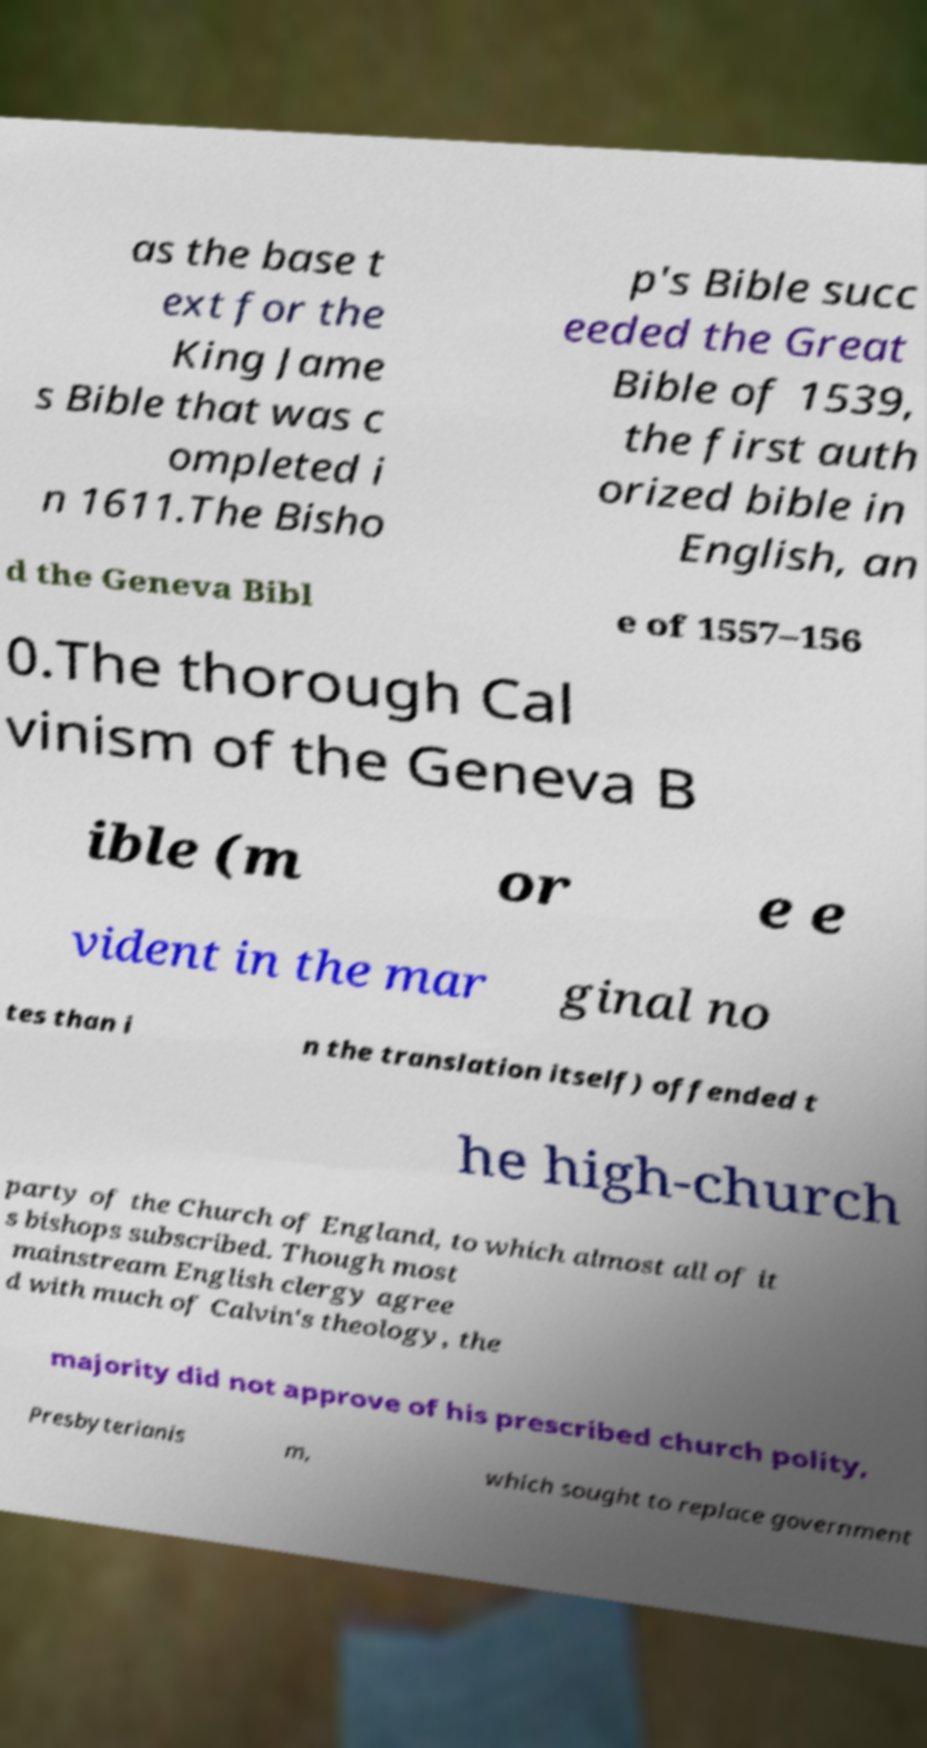I need the written content from this picture converted into text. Can you do that? as the base t ext for the King Jame s Bible that was c ompleted i n 1611.The Bisho p's Bible succ eeded the Great Bible of 1539, the first auth orized bible in English, an d the Geneva Bibl e of 1557–156 0.The thorough Cal vinism of the Geneva B ible (m or e e vident in the mar ginal no tes than i n the translation itself) offended t he high-church party of the Church of England, to which almost all of it s bishops subscribed. Though most mainstream English clergy agree d with much of Calvin's theology, the majority did not approve of his prescribed church polity, Presbyterianis m, which sought to replace government 